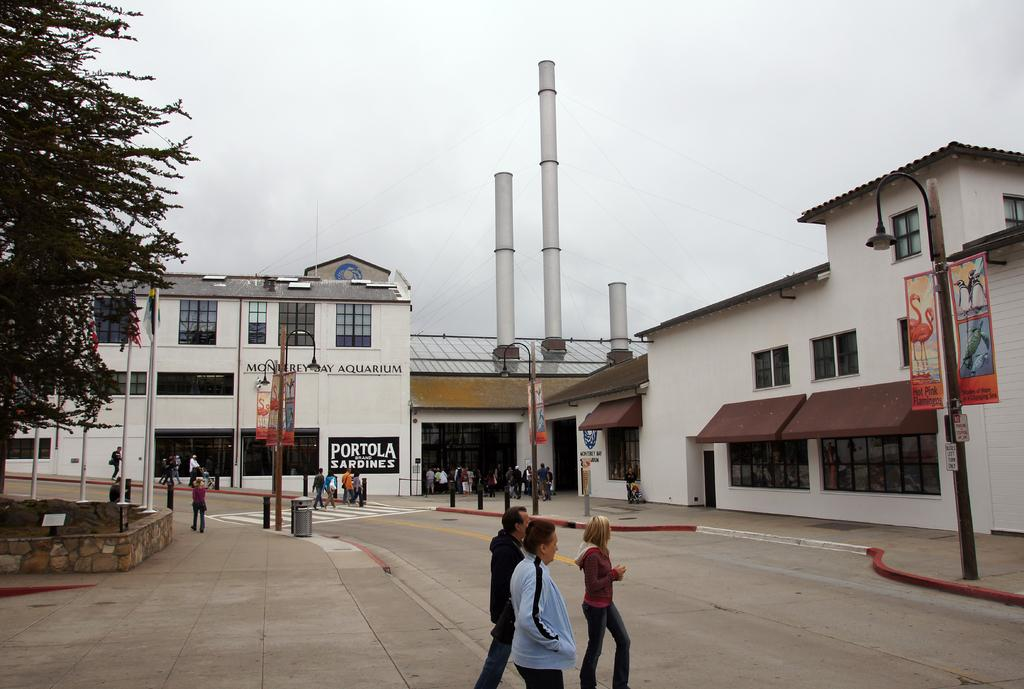What type of structures can be seen in the image? There are buildings in the image. What features are present on the buildings? There are chimneys on the buildings. What other objects can be seen on the streets? There are street poles, street lights, and bins in the image. What is attached to the street poles? There are advertisements attached to the poles in the image. What type of vegetation is present in the image? There are trees in the image. What can be seen flying in the image? There are flags in the image. Where are the flags attached? There are flag posts in the image. What is happening on the road in the image? There are people on the road in the image. Can you hear the sky laughing in the image? The sky cannot laugh, as it is a natural phenomenon and not a living being. Additionally, the image is a visual representation and does not contain any auditory information. 